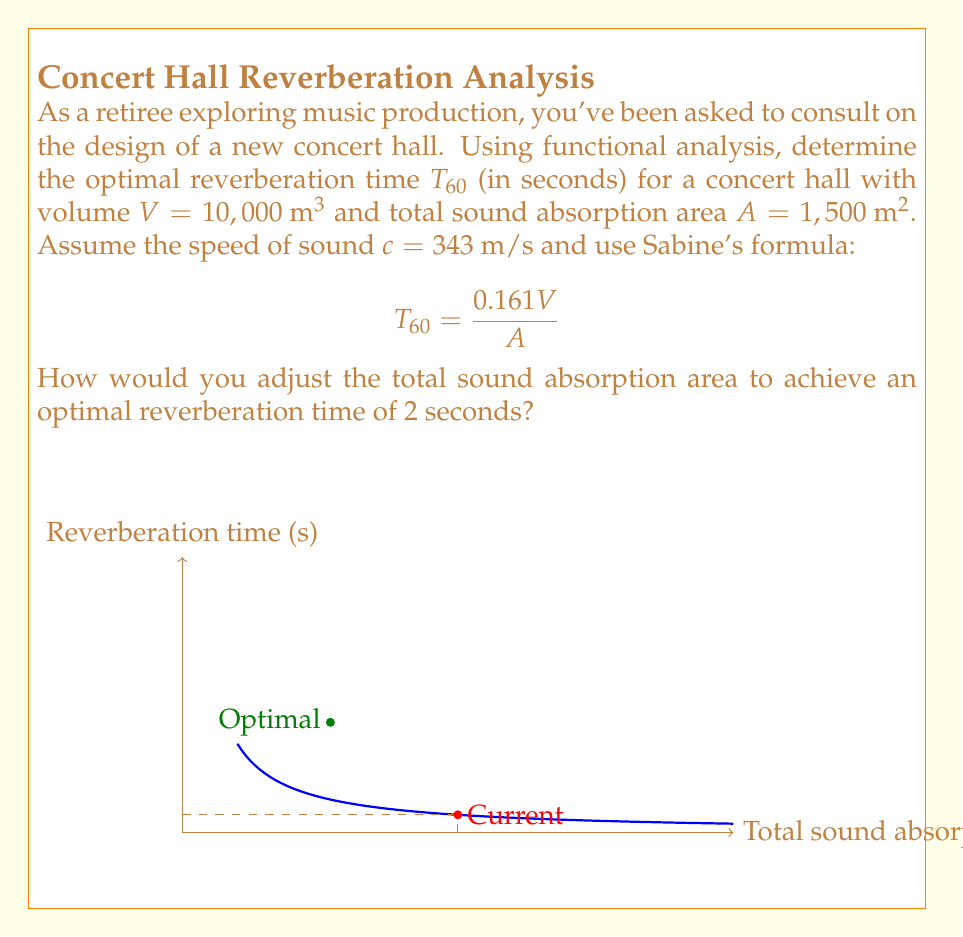Give your solution to this math problem. Let's approach this step-by-step:

1) First, we need to calculate the current reverberation time using the given values:

   $T_{60} = \frac{0.161V}{A} = \frac{0.161 \cdot 10,000}{1,500} = 1.07 \text{ seconds}$

2) We want to adjust the total sound absorption area $A$ to achieve an optimal reverberation time of 2 seconds. Let's call this new area $A_{new}$.

3) We can set up the equation:

   $2 = \frac{0.161 \cdot 10,000}{A_{new}}$

4) Solving for $A_{new}$:

   $A_{new} = \frac{0.161 \cdot 10,000}{2} = 805 \text{ m}^2$

5) To find how much we need to adjust the area, we calculate the difference:

   $\Delta A = 1,500 - 805 = 695 \text{ m}^2$

6) This means we need to reduce the total sound absorption area by 695 m^2 to achieve the optimal reverberation time.

7) In terms of functional analysis, we can view the reverberation time as a function of the sound absorption area:

   $T(A) = \frac{0.161V}{A}$

   This is a hyperbolic function, which explains the shape of the graph in the question.

8) The optimal point $(805, 2)$ represents the solution to our problem on this function.
Answer: Reduce total sound absorption area by 695 m^2 